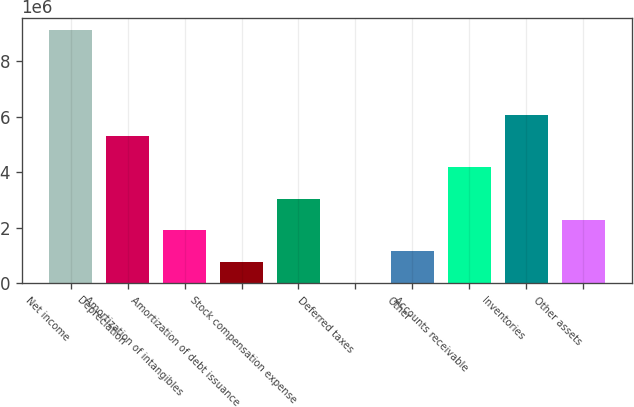Convert chart. <chart><loc_0><loc_0><loc_500><loc_500><bar_chart><fcel>Net income<fcel>Depreciation<fcel>Amortization of intangibles<fcel>Amortization of debt issuance<fcel>Stock compensation expense<fcel>Deferred taxes<fcel>Other<fcel>Accounts receivable<fcel>Inventories<fcel>Other assets<nl><fcel>9.10509e+06<fcel>5.31498e+06<fcel>1.90389e+06<fcel>766857<fcel>3.04092e+06<fcel>8836<fcel>1.14587e+06<fcel>4.17795e+06<fcel>6.07301e+06<fcel>2.2829e+06<nl></chart> 